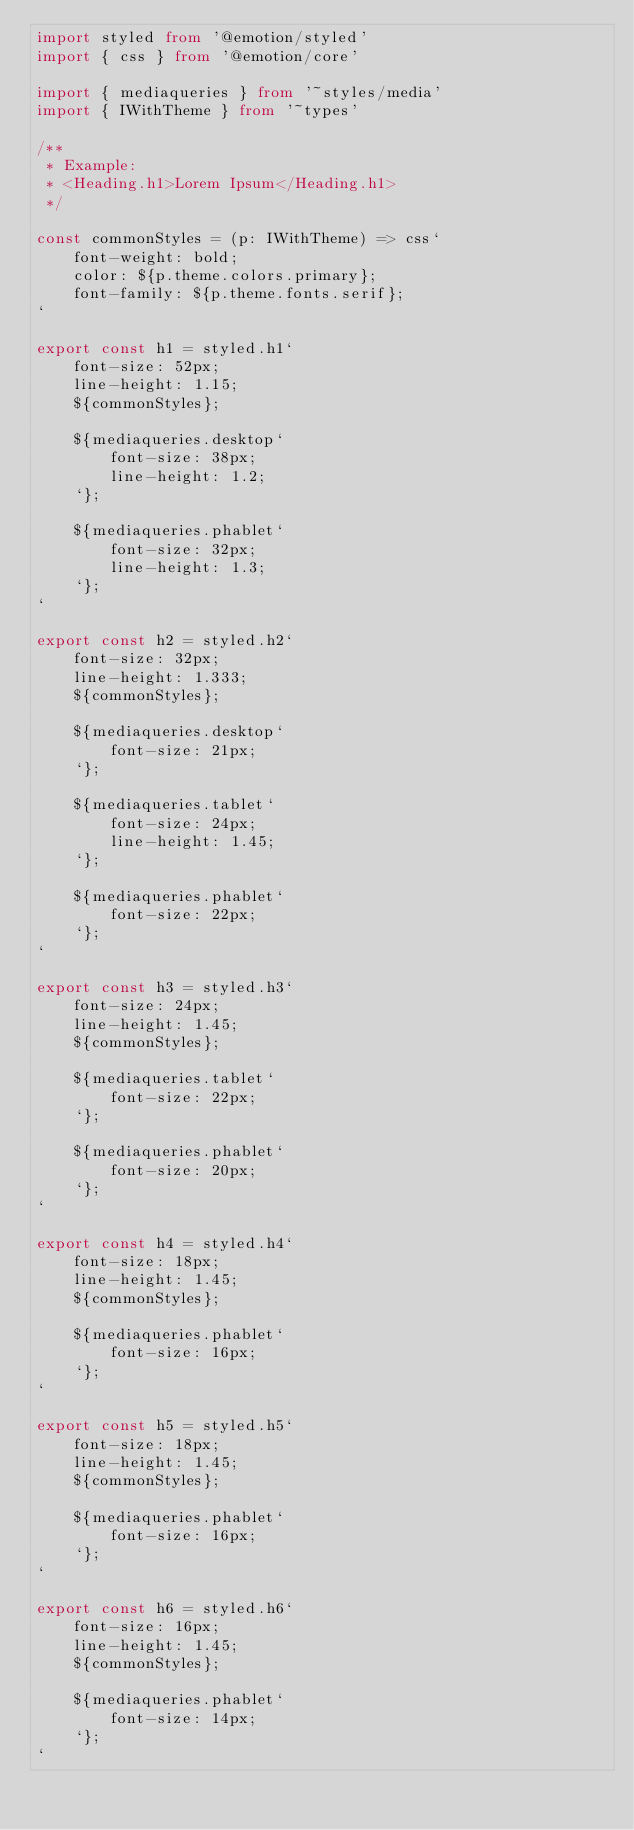<code> <loc_0><loc_0><loc_500><loc_500><_TypeScript_>import styled from '@emotion/styled'
import { css } from '@emotion/core'

import { mediaqueries } from '~styles/media'
import { IWithTheme } from '~types'

/**
 * Example:
 * <Heading.h1>Lorem Ipsum</Heading.h1>
 */

const commonStyles = (p: IWithTheme) => css`
    font-weight: bold;
    color: ${p.theme.colors.primary};
    font-family: ${p.theme.fonts.serif};
`

export const h1 = styled.h1`
    font-size: 52px;
    line-height: 1.15;
    ${commonStyles};

    ${mediaqueries.desktop`
        font-size: 38px;
        line-height: 1.2;
    `};

    ${mediaqueries.phablet`
        font-size: 32px;
        line-height: 1.3;
    `};
`

export const h2 = styled.h2`
    font-size: 32px;
    line-height: 1.333;
    ${commonStyles};

    ${mediaqueries.desktop`
        font-size: 21px;
    `};

    ${mediaqueries.tablet`
        font-size: 24px;
        line-height: 1.45;
    `};

    ${mediaqueries.phablet`
        font-size: 22px;
    `};
`

export const h3 = styled.h3`
    font-size: 24px;
    line-height: 1.45;
    ${commonStyles};

    ${mediaqueries.tablet`
        font-size: 22px;
    `};

    ${mediaqueries.phablet`
        font-size: 20px;
    `};
`

export const h4 = styled.h4`
    font-size: 18px;
    line-height: 1.45;
    ${commonStyles};

    ${mediaqueries.phablet`
        font-size: 16px;
    `};
`

export const h5 = styled.h5`
    font-size: 18px;
    line-height: 1.45;
    ${commonStyles};

    ${mediaqueries.phablet`
        font-size: 16px;
    `};
`

export const h6 = styled.h6`
    font-size: 16px;
    line-height: 1.45;
    ${commonStyles};

    ${mediaqueries.phablet`
        font-size: 14px;
    `};
`
</code> 